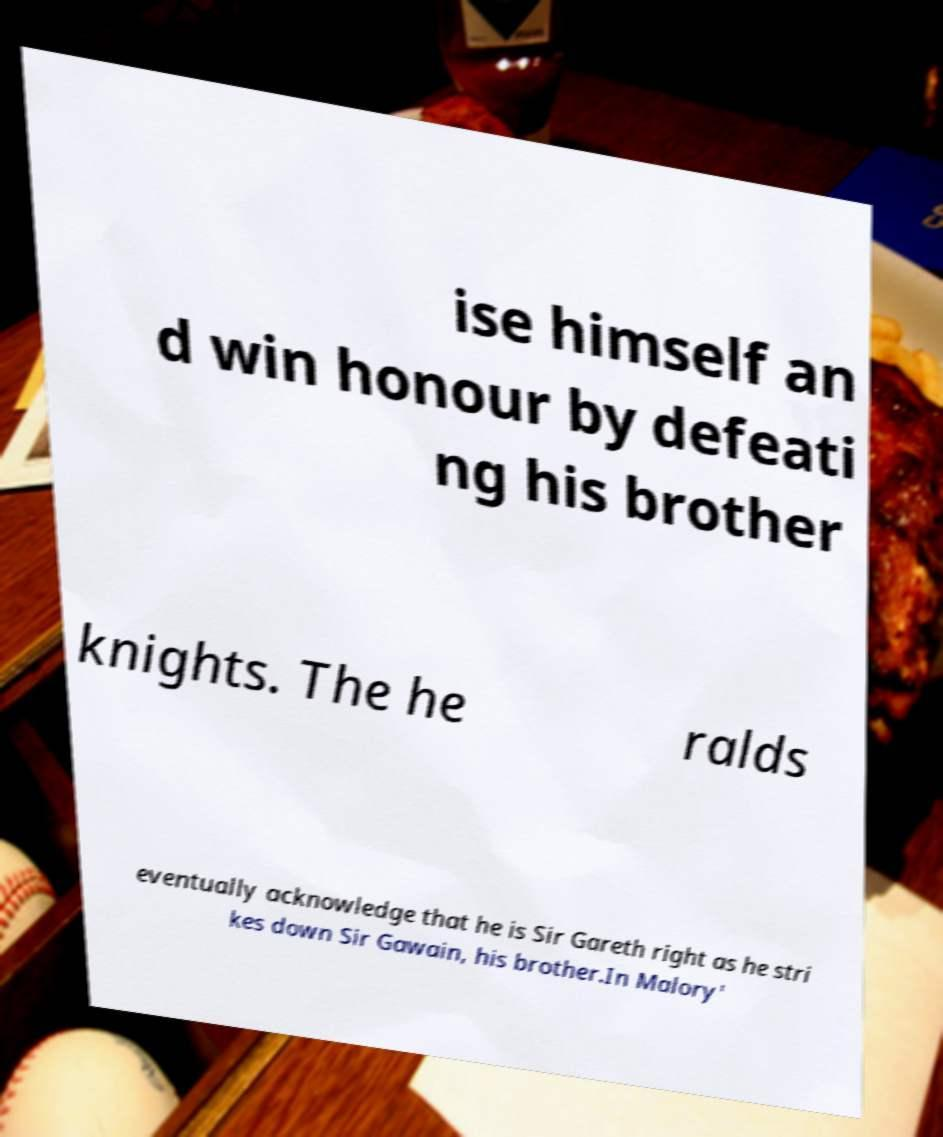Please read and relay the text visible in this image. What does it say? ise himself an d win honour by defeati ng his brother knights. The he ralds eventually acknowledge that he is Sir Gareth right as he stri kes down Sir Gawain, his brother.In Malory' 